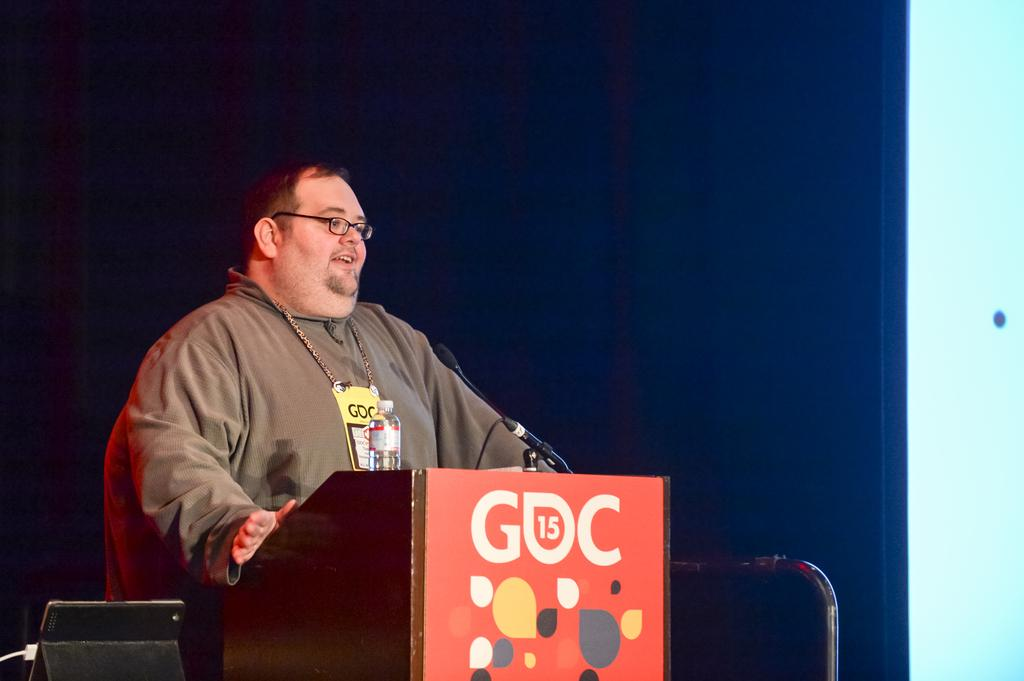Who is the main subject in the image? There is a man in the image. What is the man doing in the image? The man is standing in front of a microphone. Can you describe the man's appearance? The man is wearing spectacles. What other objects are present in the image? There is a podium and a bottle in the image. What time of day is it in the image, and who is the representative speaking to? The time of day is not mentioned in the image, and there is no representative or indication of who the man is speaking to. 